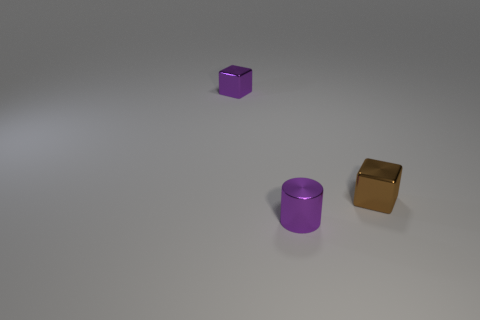If these objects were to represent a modern art installation, what title might you give it and why? A fitting title for this modern art installation could be 'Geometric Solitude.' The title reflects the sparse arrangement and the isolation of geometric forms, which may inspire contemplation on the nature of spatial relationships and form. 